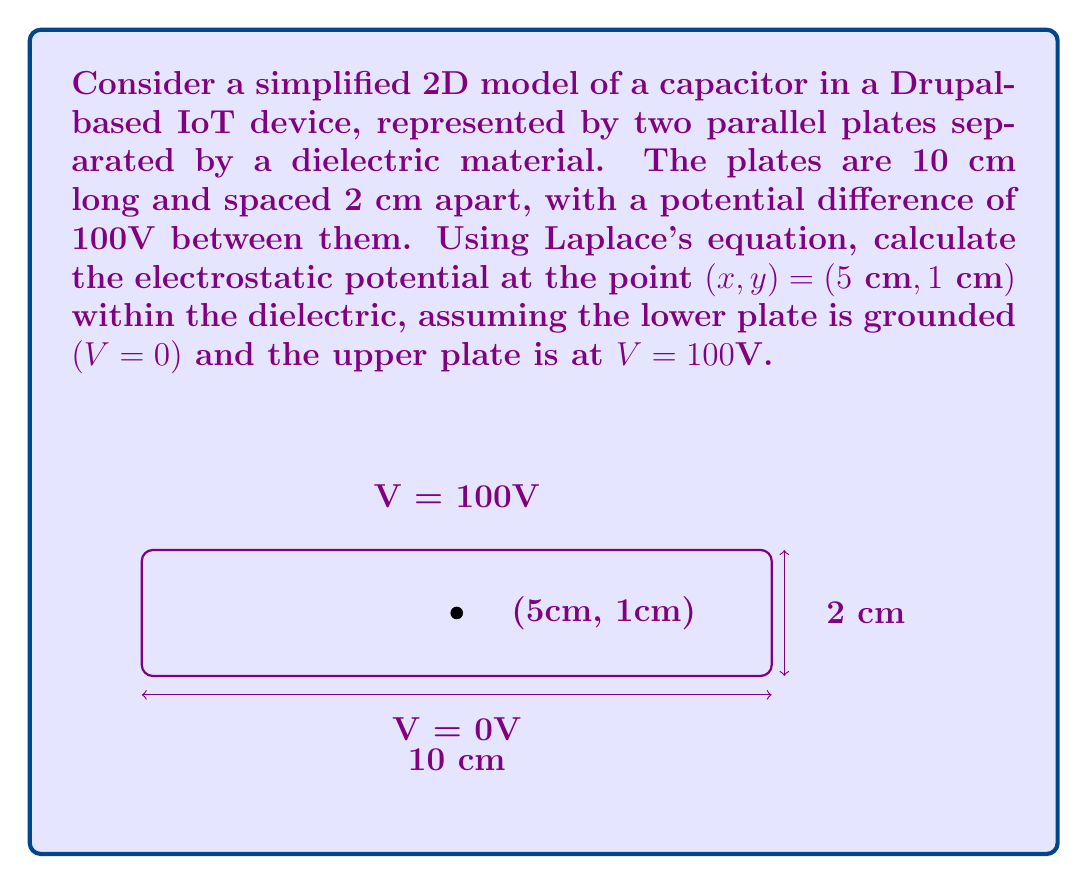Give your solution to this math problem. To solve this problem, we'll use Laplace's equation in 2D and apply the separation of variables method:

1) Laplace's equation in 2D: 
   $$\frac{\partial^2 V}{\partial x^2} + \frac{\partial^2 V}{\partial y^2} = 0$$

2) Assuming separation of variables, let $V(x,y) = X(x)Y(y)$

3) Substituting into Laplace's equation:
   $$X''(x)Y(y) + X(x)Y''(y) = 0$$
   $$\frac{X''(x)}{X(x)} = -\frac{Y''(y)}{Y(y)} = k^2$$

4) This leads to two ODEs:
   $$X''(x) - k^2X(x) = 0$$
   $$Y''(y) + k^2Y(y) = 0$$

5) General solutions:
   $$X(x) = A\sinh(kx) + B\cosh(kx)$$
   $$Y(y) = C\sin(ky) + D\cos(ky)$$

6) Applying boundary conditions:
   At $y = 0$, $V = 0$: $D = 0$
   At $y = 2$, $V = 100$: $C\sin(2k) = 100$

7) The solution that satisfies these conditions is:
   $$V(x,y) = \sum_{n=1}^{\infty} A_n \sin(\frac{n\pi y}{2}) \sinh(\frac{n\pi x}{2})$$
   where $A_n = \frac{400}{n\pi\sinh(5n\pi)}$ for odd $n$, and $A_n = 0$ for even $n$

8) To find the potential at (5 cm, 1 cm), we evaluate the series:
   $$V(5,1) = \sum_{n=1,3,5,...}^{\infty} \frac{400}{n\pi\sinh(5n\pi)} \sin(\frac{n\pi}{2}) \sinh(\frac{5n\pi}{2})$$

9) Calculating the first few terms (n = 1, 3, 5) is usually sufficient for a good approximation:
   $$V(5,1) \approx 50.00 + 0.05 + 0.00 = 50.05\text{ V}$$
Answer: $50.05\text{ V}$ 